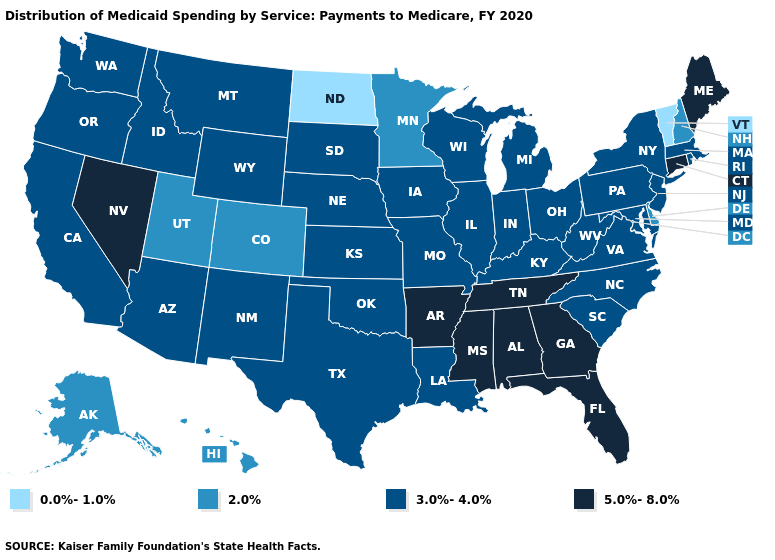Name the states that have a value in the range 0.0%-1.0%?
Concise answer only. North Dakota, Vermont. Does Michigan have the lowest value in the MidWest?
Be succinct. No. What is the lowest value in states that border New Jersey?
Give a very brief answer. 2.0%. Name the states that have a value in the range 0.0%-1.0%?
Short answer required. North Dakota, Vermont. Among the states that border Alabama , which have the highest value?
Keep it brief. Florida, Georgia, Mississippi, Tennessee. Does Georgia have a higher value than Texas?
Quick response, please. Yes. Is the legend a continuous bar?
Give a very brief answer. No. What is the value of South Dakota?
Keep it brief. 3.0%-4.0%. Does Alaska have the same value as Wyoming?
Be succinct. No. What is the highest value in states that border North Carolina?
Answer briefly. 5.0%-8.0%. Which states have the lowest value in the USA?
Concise answer only. North Dakota, Vermont. Does Hawaii have a lower value than Oregon?
Keep it brief. Yes. Does Alaska have the same value as Hawaii?
Keep it brief. Yes. What is the value of Oregon?
Keep it brief. 3.0%-4.0%. 